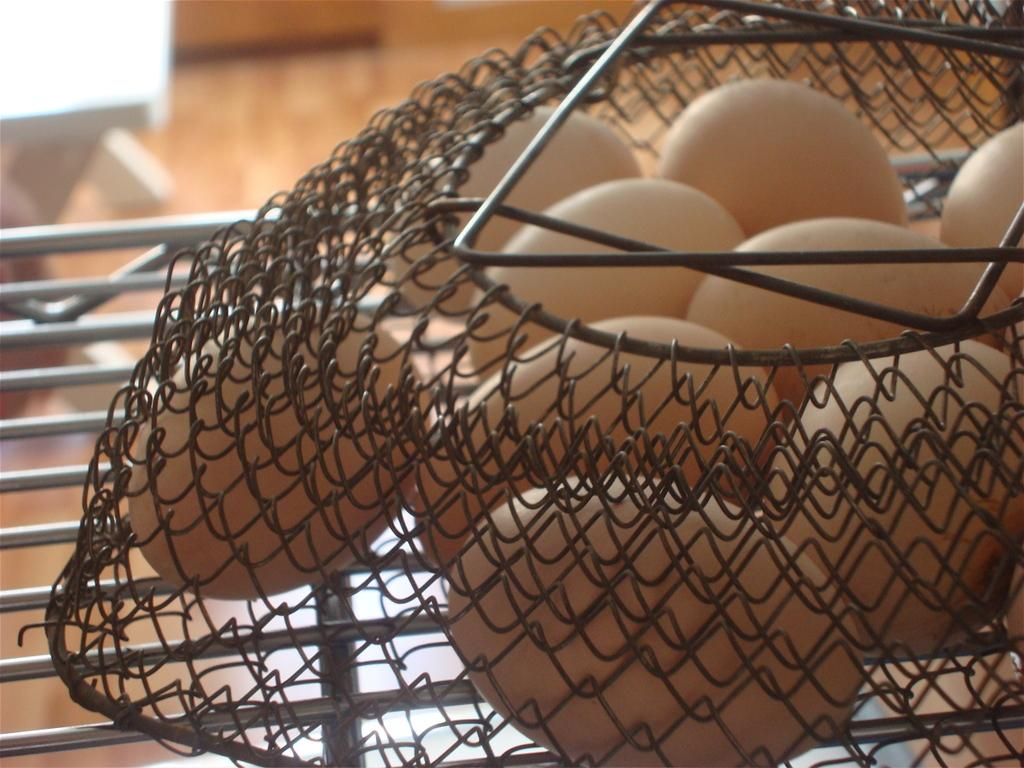What is present in the image? There are eggs in the image. How are the eggs arranged or stored? The eggs are in a wire storage basket. Can you describe the background of the image? The background of the image is blurry. Where is the nest located in the image? There is no nest present in the image. What type of cabbage can be seen growing in the background of the image? There is no cabbage visible in the image; the background is blurry. 